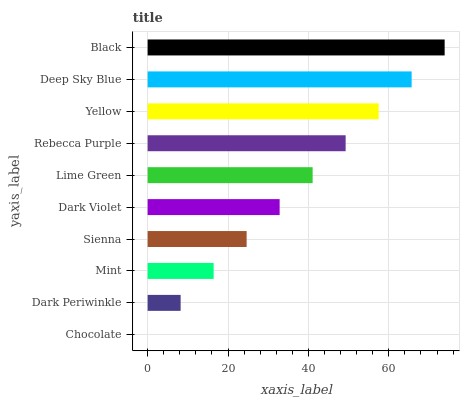Is Chocolate the minimum?
Answer yes or no. Yes. Is Black the maximum?
Answer yes or no. Yes. Is Dark Periwinkle the minimum?
Answer yes or no. No. Is Dark Periwinkle the maximum?
Answer yes or no. No. Is Dark Periwinkle greater than Chocolate?
Answer yes or no. Yes. Is Chocolate less than Dark Periwinkle?
Answer yes or no. Yes. Is Chocolate greater than Dark Periwinkle?
Answer yes or no. No. Is Dark Periwinkle less than Chocolate?
Answer yes or no. No. Is Lime Green the high median?
Answer yes or no. Yes. Is Dark Violet the low median?
Answer yes or no. Yes. Is Black the high median?
Answer yes or no. No. Is Black the low median?
Answer yes or no. No. 